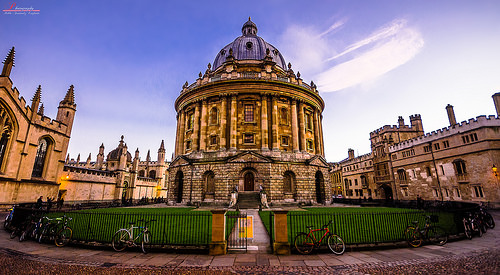<image>
Is there a bike behind the fence? No. The bike is not behind the fence. From this viewpoint, the bike appears to be positioned elsewhere in the scene. 